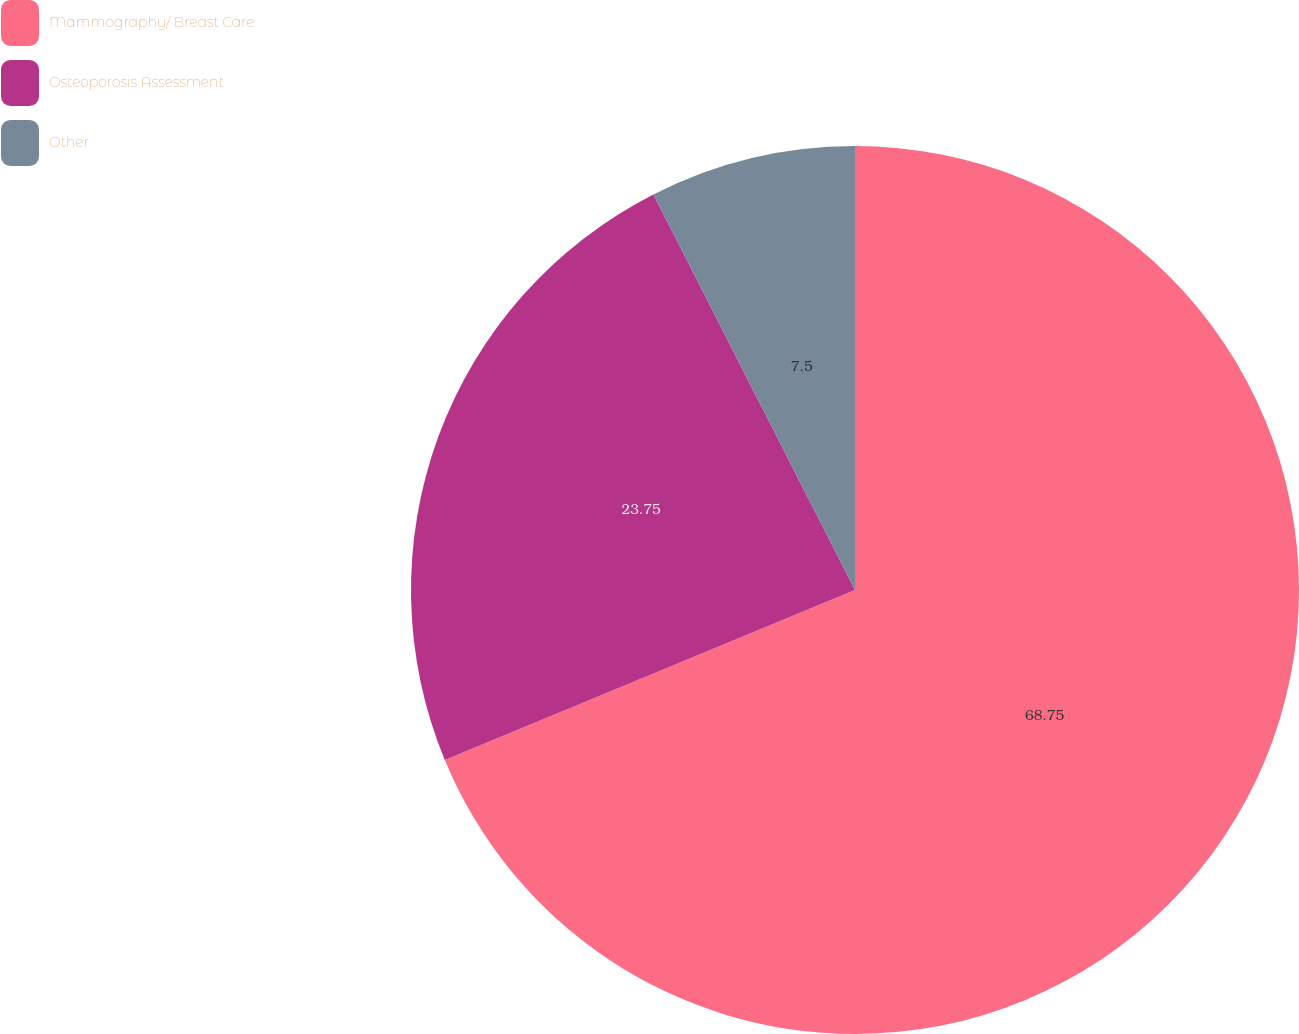Convert chart. <chart><loc_0><loc_0><loc_500><loc_500><pie_chart><fcel>Mammography/ Breast Care<fcel>Osteoporosis Assessment<fcel>Other<nl><fcel>68.75%<fcel>23.75%<fcel>7.5%<nl></chart> 